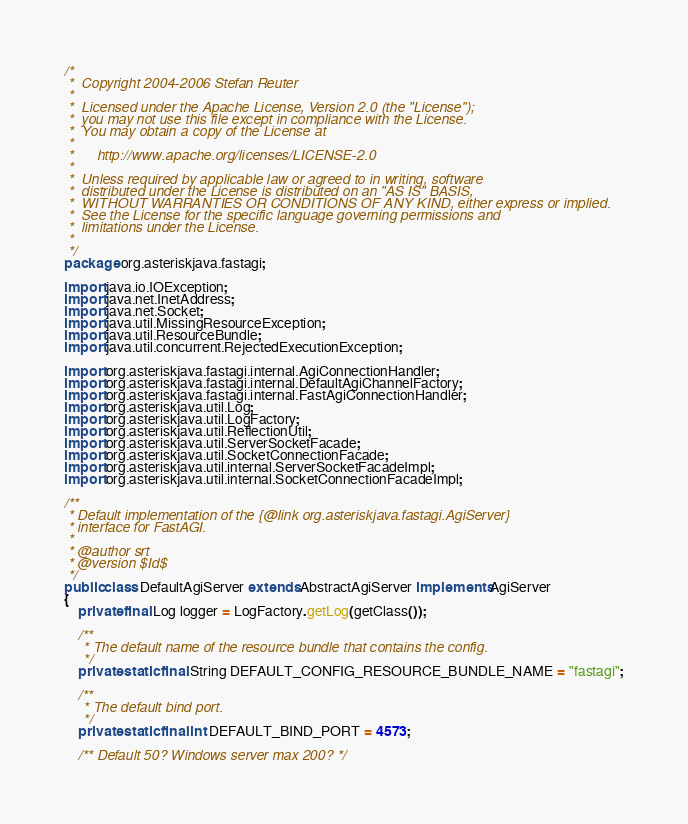Convert code to text. <code><loc_0><loc_0><loc_500><loc_500><_Java_>/*
 *  Copyright 2004-2006 Stefan Reuter
 *
 *  Licensed under the Apache License, Version 2.0 (the "License");
 *  you may not use this file except in compliance with the License.
 *  You may obtain a copy of the License at
 *
 *      http://www.apache.org/licenses/LICENSE-2.0
 *
 *  Unless required by applicable law or agreed to in writing, software
 *  distributed under the License is distributed on an "AS IS" BASIS,
 *  WITHOUT WARRANTIES OR CONDITIONS OF ANY KIND, either express or implied.
 *  See the License for the specific language governing permissions and
 *  limitations under the License.
 *
 */
package org.asteriskjava.fastagi;

import java.io.IOException;
import java.net.InetAddress;
import java.net.Socket;
import java.util.MissingResourceException;
import java.util.ResourceBundle;
import java.util.concurrent.RejectedExecutionException;

import org.asteriskjava.fastagi.internal.AgiConnectionHandler;
import org.asteriskjava.fastagi.internal.DefaultAgiChannelFactory;
import org.asteriskjava.fastagi.internal.FastAgiConnectionHandler;
import org.asteriskjava.util.Log;
import org.asteriskjava.util.LogFactory;
import org.asteriskjava.util.ReflectionUtil;
import org.asteriskjava.util.ServerSocketFacade;
import org.asteriskjava.util.SocketConnectionFacade;
import org.asteriskjava.util.internal.ServerSocketFacadeImpl;
import org.asteriskjava.util.internal.SocketConnectionFacadeImpl;

/**
 * Default implementation of the {@link org.asteriskjava.fastagi.AgiServer}
 * interface for FastAGI.
 *
 * @author srt
 * @version $Id$
 */
public class DefaultAgiServer extends AbstractAgiServer implements AgiServer
{
    private final Log logger = LogFactory.getLog(getClass());

    /**
     * The default name of the resource bundle that contains the config.
     */
    private static final String DEFAULT_CONFIG_RESOURCE_BUNDLE_NAME = "fastagi";

    /**
     * The default bind port.
     */
    private static final int DEFAULT_BIND_PORT = 4573;

    /** Default 50? Windows server max 200? */</code> 